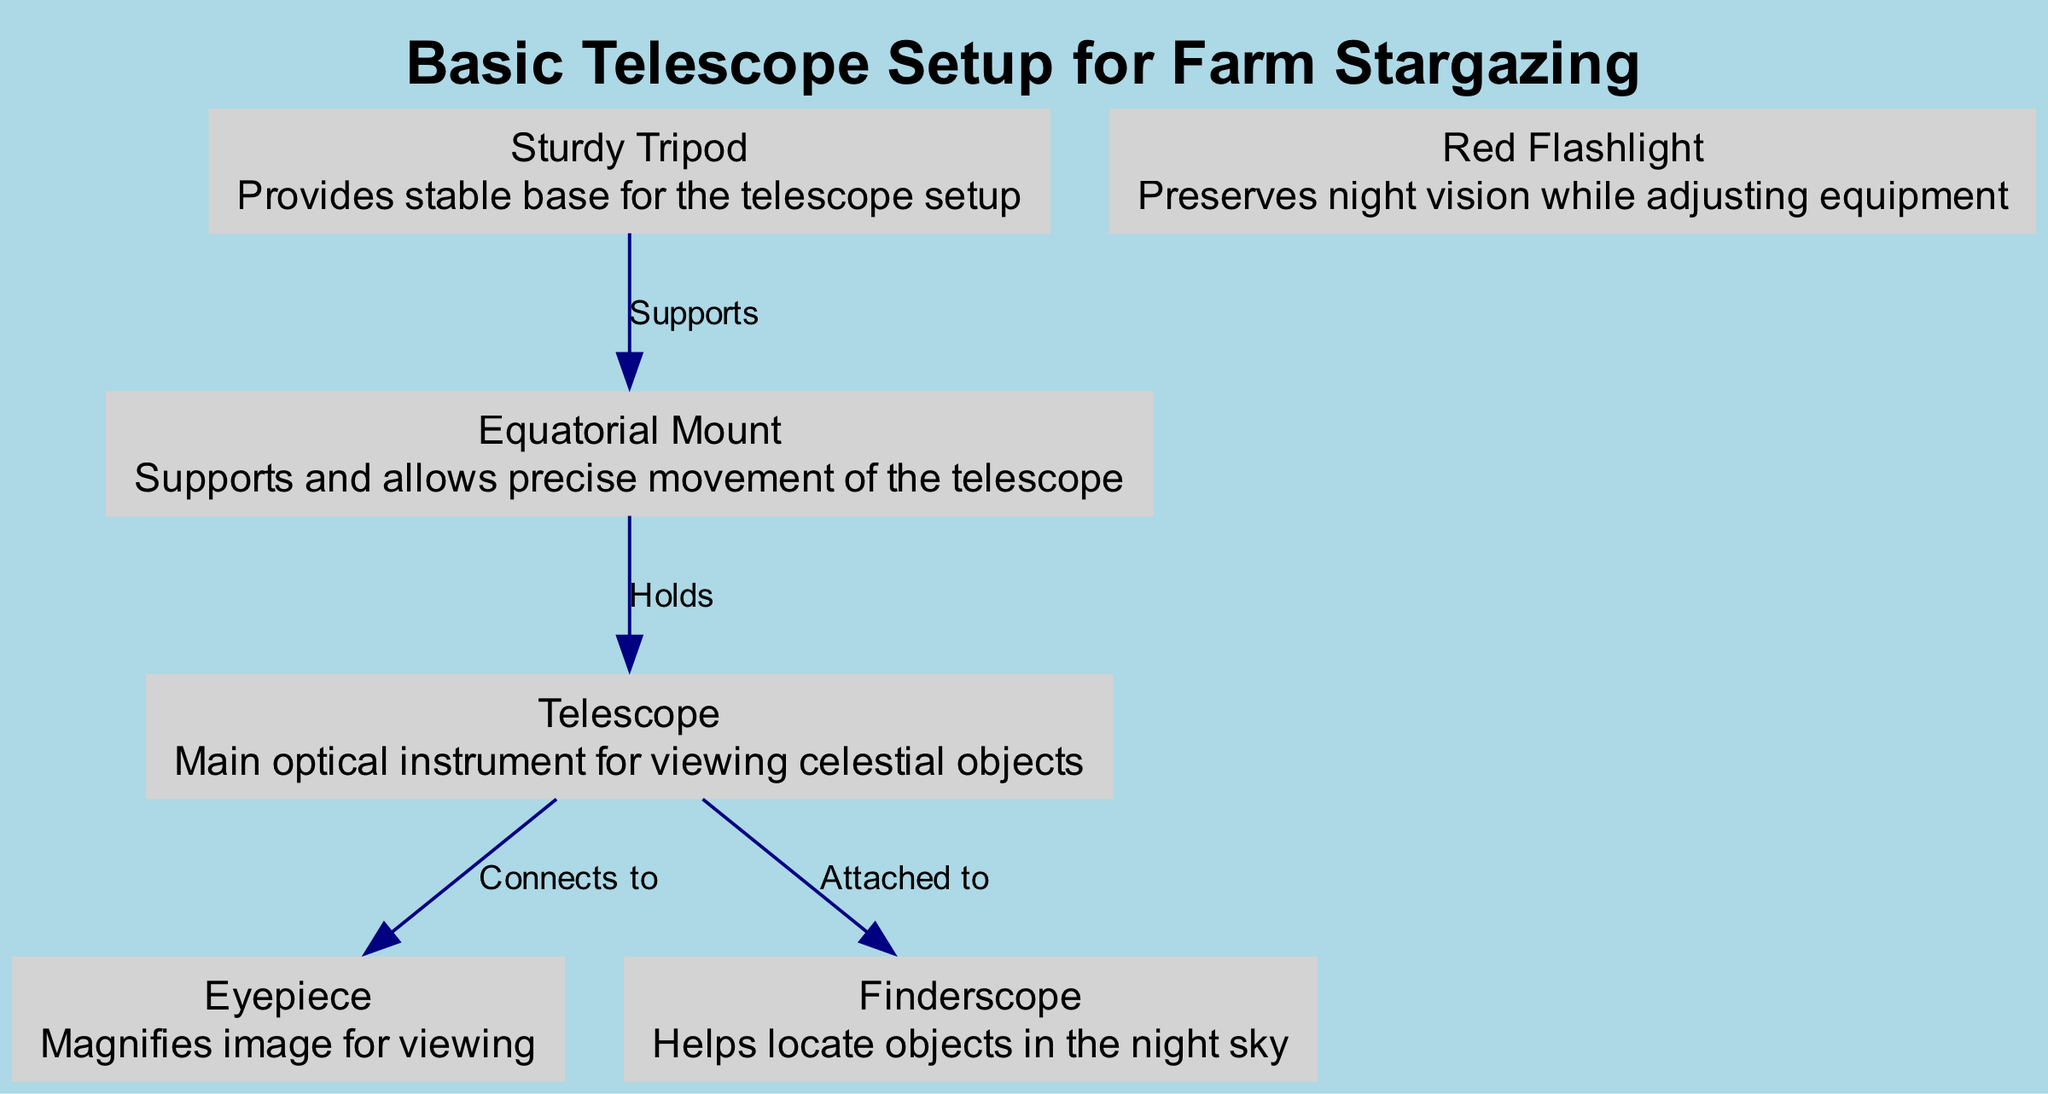What is the main optical instrument in the setup? The diagram labels a node called "Telescope," which is defined as the main optical instrument for viewing celestial objects. Hence, the answer is based solely on the label and description provided for that specific node.
Answer: Telescope What component helps locate objects in the night sky? The diagram includes a node labeled "Finderscope." This node's description states it helps locate objects in the night sky, making it clear that this is the required answer.
Answer: Finderscope How many nodes are depicted in the diagram? The diagram lists six distinct nodes: Telescope, Equatorial Mount, Sturdy Tripod, Eyepiece, Finderscope, and Red Flashlight. Counting these nodes gives a total of six, which directly answers the question.
Answer: 6 What supports the equatorial mount? The diagram illustrates an edge labeled "Supports" that connects the "Tripod" node to the "Equatorial Mount" node. This indicates that the tripod is the component providing support to the equatorial mount.
Answer: Tripod What connects to the telescope for viewing? The diagram includes an edge labeled "Connects to" between the "Telescope" node and the "Eyepiece" node. This signifies that the eyepiece is the direct connection for viewing through the telescope.
Answer: Eyepiece Which component preserves night vision? According to the diagram, the "Red Flashlight" node is specifically described as preserving night vision while adjusting equipment. This information directly highlights its function in the setup.
Answer: Red Flashlight What is the relationship between the telescope and the finderscope? The diagram shows an edge labeled "Attached to" connecting the "Telescope" node to the "Finderscope" node. This indicates that the finderscope is physically attached to the telescope, defining their relationship clearly.
Answer: Attached to Which type of mount is used in this setup? The diagram specifies the "Equatorial Mount" as the type of mount used, which is a straightforward identification based on the label of the node in the diagram.
Answer: Equatorial Mount What provides a stable base for the telescope setup? The diagram indicates that a node labeled "Sturdy Tripod" is responsible for providing a stable base. This is evident from the description that accompanies the tripod node.
Answer: Sturdy Tripod 